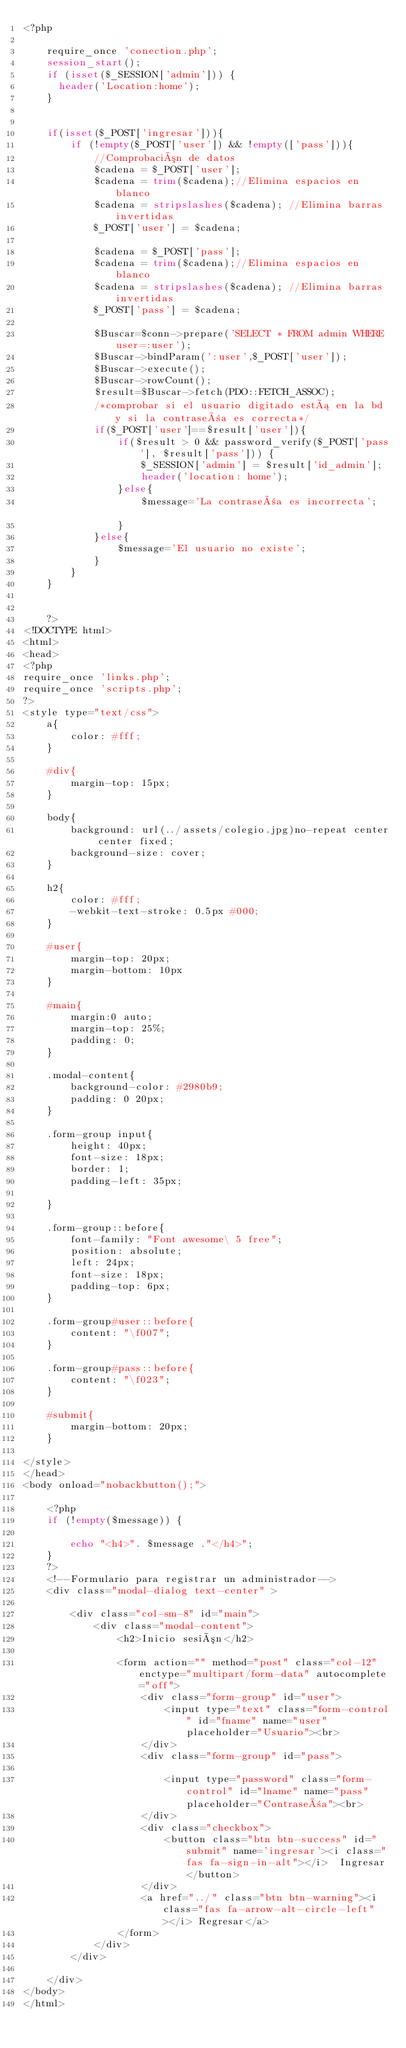Convert code to text. <code><loc_0><loc_0><loc_500><loc_500><_PHP_><?php

	require_once 'conection.php';
	session_start();
    if (isset($_SESSION['admin'])) {
      header('Location:home');
    }


	if(isset($_POST['ingresar'])){
		if (!empty($_POST['user']) && !empty(['pass'])){
			//Comprobación de datos
			$cadena = $_POST['user'];
			$cadena = trim($cadena);//Elimina espacios en blanco
			$cadena = stripslashes($cadena); //Elimina barras invertidas
			$_POST['user'] = $cadena;

			$cadena = $_POST['pass'];
			$cadena = trim($cadena);//Elimina espacios en blanco
			$cadena = stripslashes($cadena); //Elimina barras invertidas
			$_POST['pass'] = $cadena;

			$Buscar=$conn->prepare('SELECT * FROM admin WHERE user=:user');
			$Buscar->bindParam(':user',$_POST['user']);
			$Buscar->execute();
			$Buscar->rowCount();
			$result=$Buscar->fetch(PDO::FETCH_ASSOC);
			/*comprobar si el usuario digitado está en la bd y si la contraseña es correcta*/
			if($_POST['user']==$result['user']){
		        if($result > 0 && password_verify($_POST['pass'], $result['pass'])) {
					$_SESSION['admin'] = $result['id_admin'];
					header('location: home');
				}else{
					$message='La contraseña es incorrecta';		
				}
			}else{
				$message='El usuario no existe';
		    }
		}
	}


	?>
<!DOCTYPE html>
<html>
<head>
<?php
require_once 'links.php';
require_once 'scripts.php';
?>
<style type="text/css">
	a{
		color: #fff;
	}

	#div{
		margin-top: 15px;
	}

	body{
		background: url(../assets/colegio.jpg)no-repeat center center fixed;
		background-size: cover;
	}

	h2{
		color: #fff;
		-webkit-text-stroke: 0.5px #000;
	}

	#user{
		margin-top: 20px;
		margin-bottom: 10px
	}

	#main{
		margin:0 auto;
		margin-top: 25%;
		padding: 0;
	}

	.modal-content{
		background-color: #2980b9;
		padding: 0 20px;
	}

	.form-group input{
		height: 40px;
		font-size: 18px;
		border: 1;
		padding-left: 35px;

	}

	.form-group::before{
		font-family: "Font awesome\ 5 free";
		position: absolute;
		left: 24px;
		font-size: 18px;
		padding-top: 6px;
	}

	.form-group#user::before{
		content: "\f007";
	}

	.form-group#pass::before{
		content: "\f023";
	}

	#submit{
		margin-bottom: 20px;
	}

</style>
</head>
<body onload="nobackbutton();">

	<?php
	if (!empty($message)) {

		echo "<h4>". $message ."</h4>";
	}
	?>
	<!--Formulario para registrar un administrador-->
	<div class="modal-dialog text-center" >

		<div class="col-sm-8" id="main">
			<div class="modal-content">
				<h2>Inicio sesión</h2>

				<form action="" method="post" class="col-12" enctype="multipart/form-data" autocomplete="off">
					<div class="form-group" id="user">
						<input type="text" class="form-control" id="fname" name="user" placeholder="Usuario"><br>
					</div>
					<div class="form-group" id="pass">

						<input type="password" class="form-control" id="lname" name="pass" placeholder="Contraseña"><br>
					</div>
					<div class="checkbox">
						<button class="btn btn-success" id="submit" name='ingresar'><i class="fas fa-sign-in-alt"></i>  Ingresar</button>
					</div>
					<a href="../" class="btn btn-warning"><i class="fas fa-arrow-alt-circle-left"></i> Regresar</a>
				</form> 
			</div>
		</div>

	</div>
</body>
</html></code> 